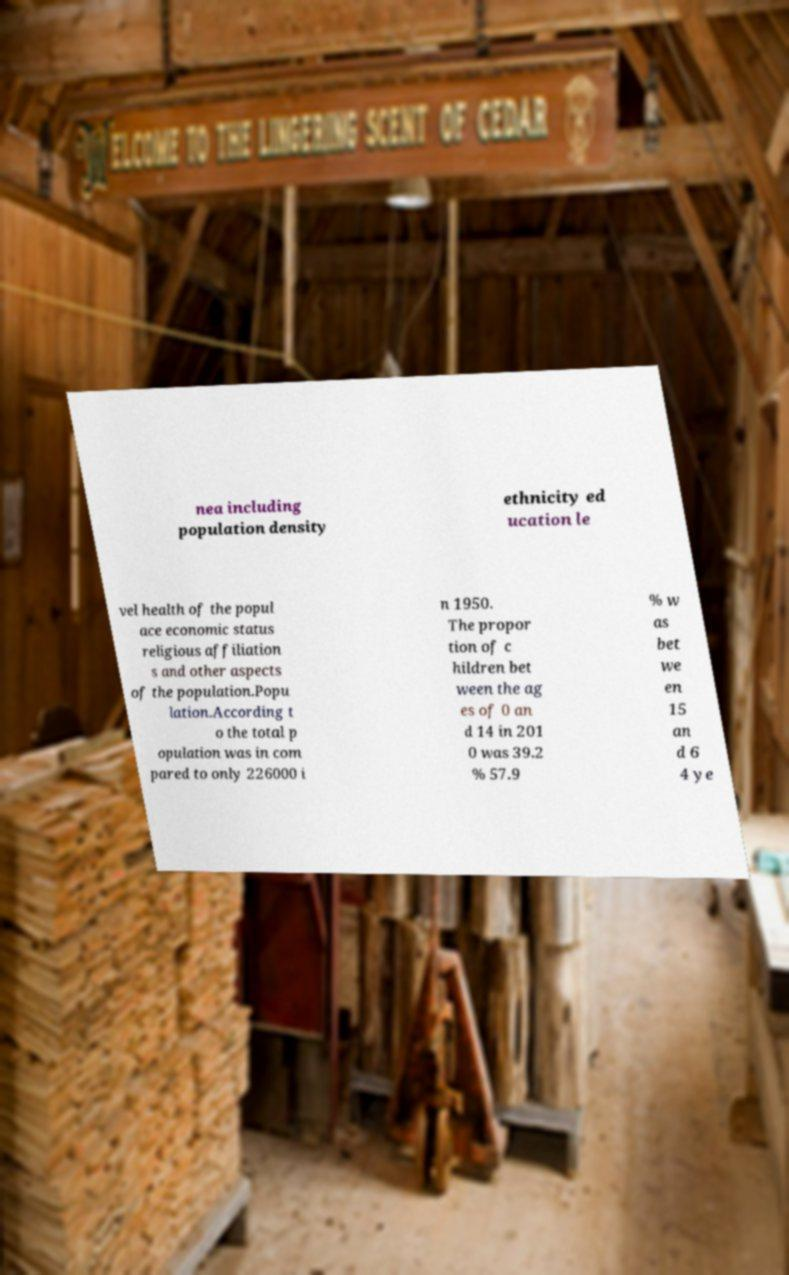Can you read and provide the text displayed in the image?This photo seems to have some interesting text. Can you extract and type it out for me? nea including population density ethnicity ed ucation le vel health of the popul ace economic status religious affiliation s and other aspects of the population.Popu lation.According t o the total p opulation was in com pared to only 226000 i n 1950. The propor tion of c hildren bet ween the ag es of 0 an d 14 in 201 0 was 39.2 % 57.9 % w as bet we en 15 an d 6 4 ye 